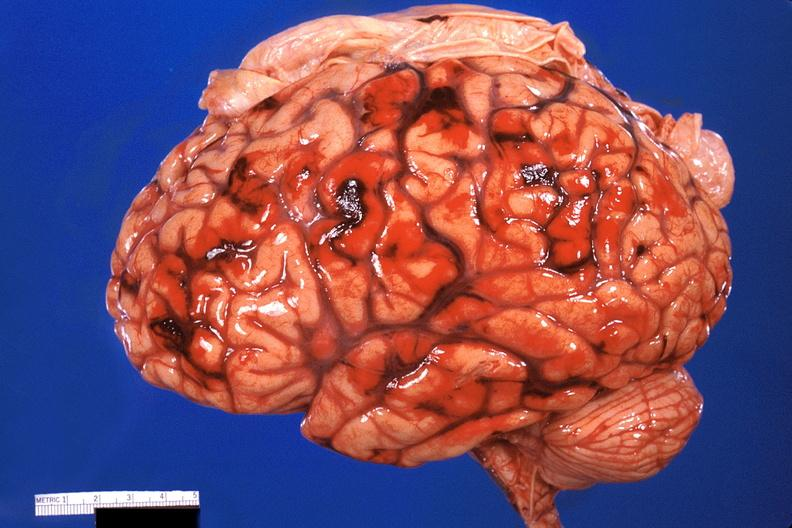s hilar cell tumor present?
Answer the question using a single word or phrase. No 